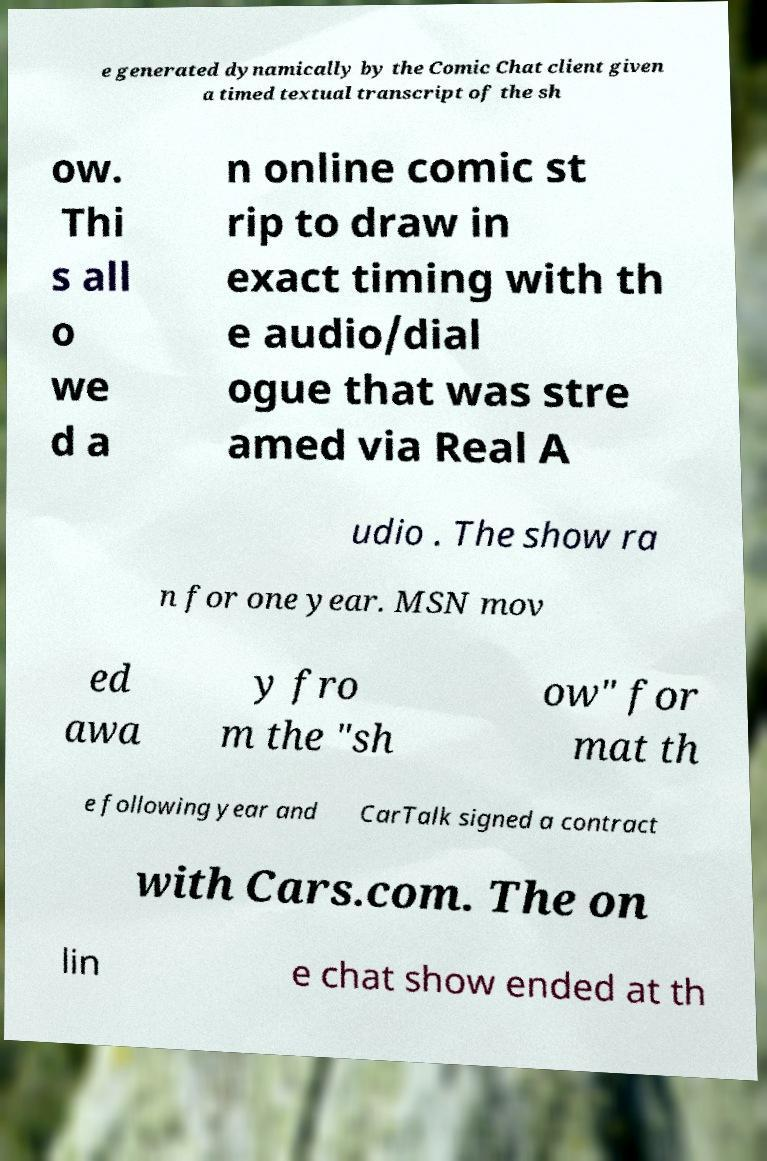There's text embedded in this image that I need extracted. Can you transcribe it verbatim? e generated dynamically by the Comic Chat client given a timed textual transcript of the sh ow. Thi s all o we d a n online comic st rip to draw in exact timing with th e audio/dial ogue that was stre amed via Real A udio . The show ra n for one year. MSN mov ed awa y fro m the "sh ow" for mat th e following year and CarTalk signed a contract with Cars.com. The on lin e chat show ended at th 